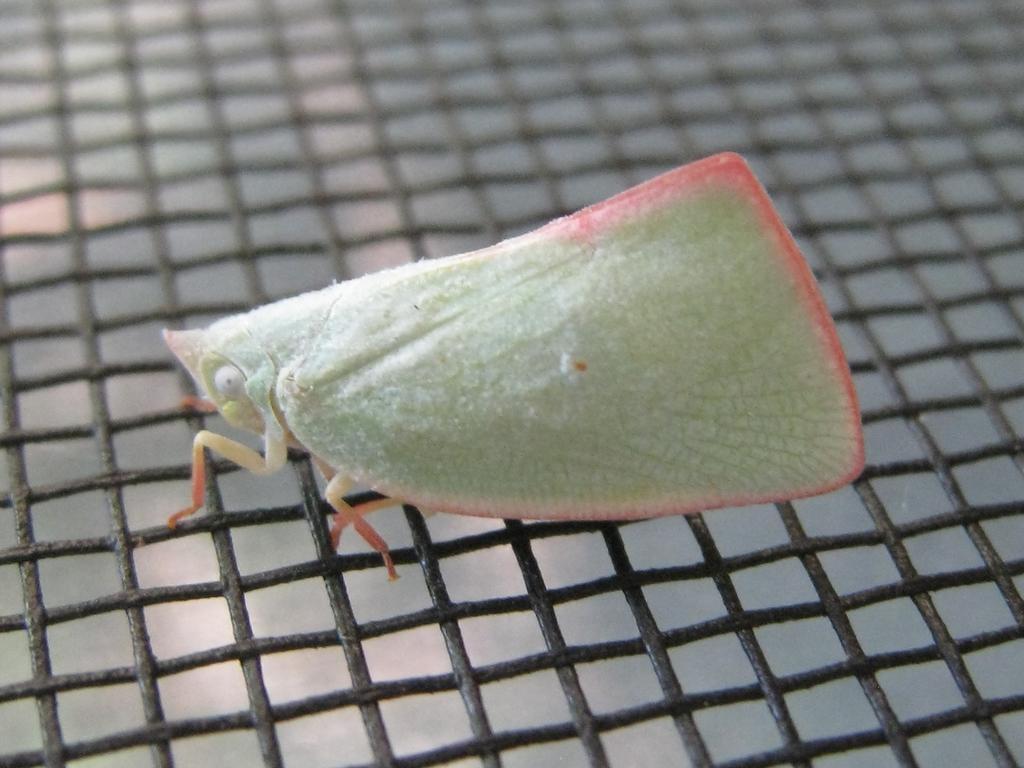How would you summarize this image in a sentence or two? In this picture we can see an insect on a mesh. 